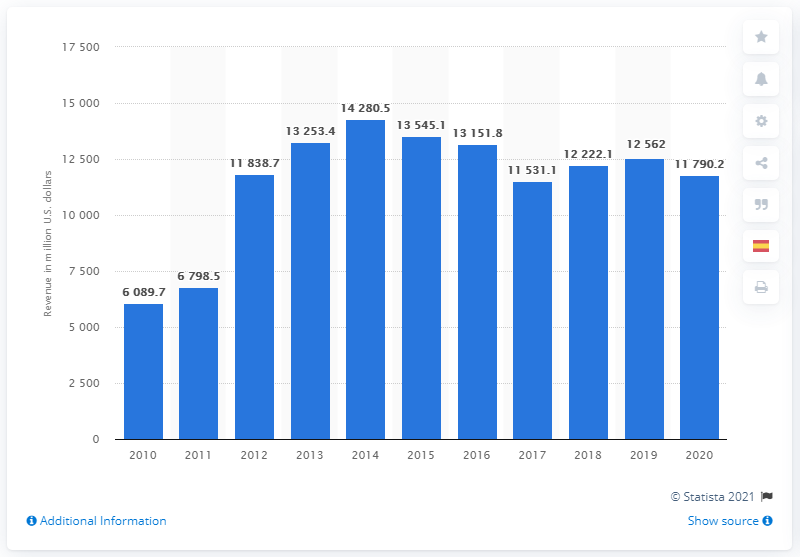Mention a couple of crucial points in this snapshot. In 2020, Ecolab generated a revenue of 11,790.2. 